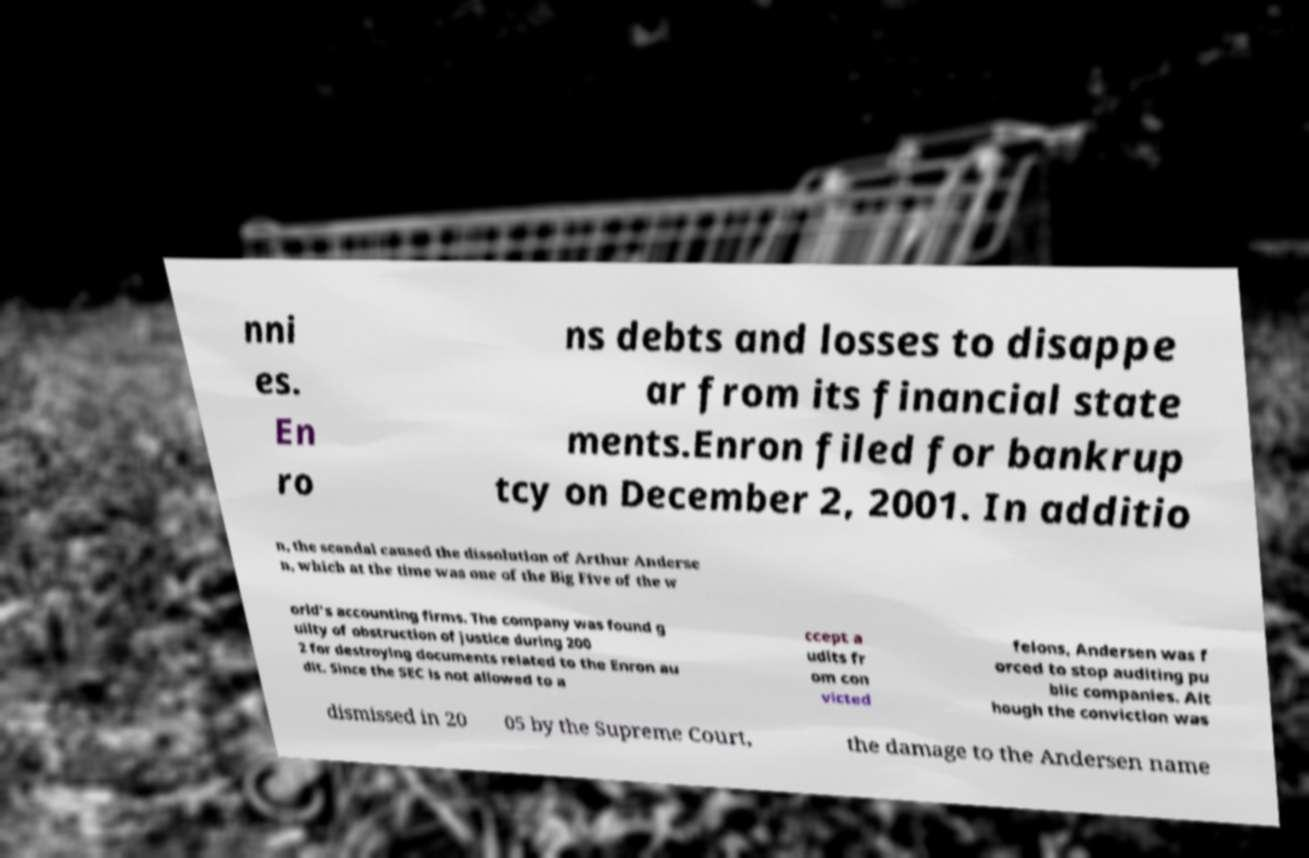There's text embedded in this image that I need extracted. Can you transcribe it verbatim? nni es. En ro ns debts and losses to disappe ar from its financial state ments.Enron filed for bankrup tcy on December 2, 2001. In additio n, the scandal caused the dissolution of Arthur Anderse n, which at the time was one of the Big Five of the w orld's accounting firms. The company was found g uilty of obstruction of justice during 200 2 for destroying documents related to the Enron au dit. Since the SEC is not allowed to a ccept a udits fr om con victed felons, Andersen was f orced to stop auditing pu blic companies. Alt hough the conviction was dismissed in 20 05 by the Supreme Court, the damage to the Andersen name 